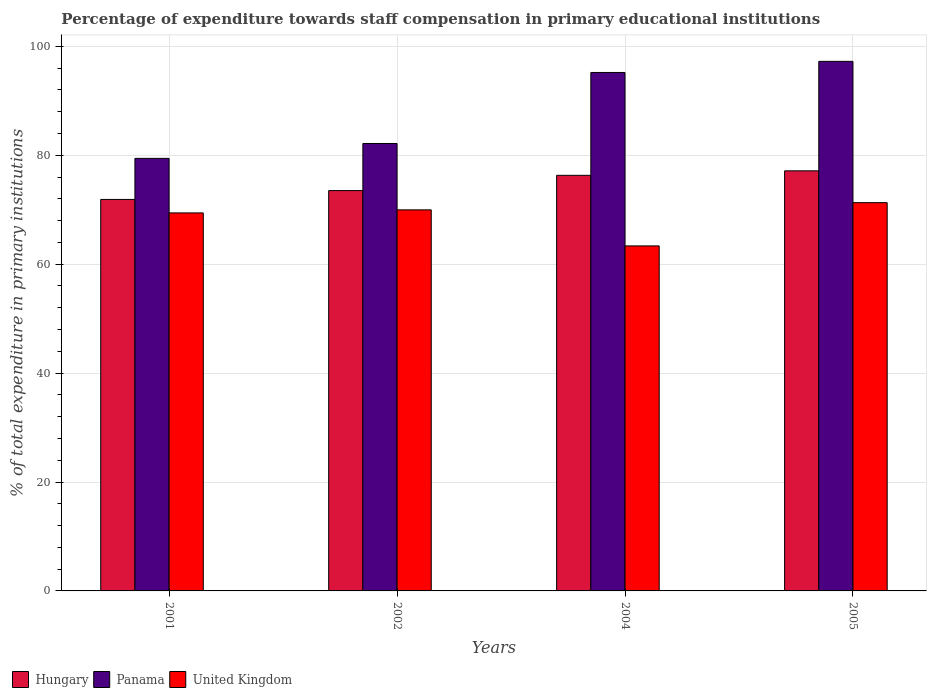How many different coloured bars are there?
Give a very brief answer. 3. Are the number of bars per tick equal to the number of legend labels?
Provide a short and direct response. Yes. What is the label of the 4th group of bars from the left?
Make the answer very short. 2005. What is the percentage of expenditure towards staff compensation in United Kingdom in 2004?
Your answer should be compact. 63.36. Across all years, what is the maximum percentage of expenditure towards staff compensation in Panama?
Keep it short and to the point. 97.25. Across all years, what is the minimum percentage of expenditure towards staff compensation in Hungary?
Provide a short and direct response. 71.89. What is the total percentage of expenditure towards staff compensation in Panama in the graph?
Your response must be concise. 354.05. What is the difference between the percentage of expenditure towards staff compensation in United Kingdom in 2004 and that in 2005?
Provide a short and direct response. -7.94. What is the difference between the percentage of expenditure towards staff compensation in Hungary in 2005 and the percentage of expenditure towards staff compensation in United Kingdom in 2002?
Give a very brief answer. 7.17. What is the average percentage of expenditure towards staff compensation in Panama per year?
Offer a terse response. 88.51. In the year 2002, what is the difference between the percentage of expenditure towards staff compensation in Hungary and percentage of expenditure towards staff compensation in United Kingdom?
Offer a terse response. 3.54. What is the ratio of the percentage of expenditure towards staff compensation in Hungary in 2002 to that in 2005?
Your answer should be very brief. 0.95. What is the difference between the highest and the second highest percentage of expenditure towards staff compensation in Hungary?
Give a very brief answer. 0.82. What is the difference between the highest and the lowest percentage of expenditure towards staff compensation in Panama?
Ensure brevity in your answer.  17.81. Is the sum of the percentage of expenditure towards staff compensation in Panama in 2002 and 2005 greater than the maximum percentage of expenditure towards staff compensation in United Kingdom across all years?
Keep it short and to the point. Yes. What does the 3rd bar from the left in 2002 represents?
Provide a short and direct response. United Kingdom. What does the 2nd bar from the right in 2004 represents?
Your response must be concise. Panama. Is it the case that in every year, the sum of the percentage of expenditure towards staff compensation in United Kingdom and percentage of expenditure towards staff compensation in Panama is greater than the percentage of expenditure towards staff compensation in Hungary?
Your response must be concise. Yes. How many bars are there?
Your response must be concise. 12. Are all the bars in the graph horizontal?
Offer a very short reply. No. How many years are there in the graph?
Ensure brevity in your answer.  4. Are the values on the major ticks of Y-axis written in scientific E-notation?
Offer a very short reply. No. Does the graph contain grids?
Offer a terse response. Yes. Where does the legend appear in the graph?
Keep it short and to the point. Bottom left. How are the legend labels stacked?
Provide a short and direct response. Horizontal. What is the title of the graph?
Your answer should be very brief. Percentage of expenditure towards staff compensation in primary educational institutions. Does "Sint Maarten (Dutch part)" appear as one of the legend labels in the graph?
Ensure brevity in your answer.  No. What is the label or title of the Y-axis?
Your response must be concise. % of total expenditure in primary institutions. What is the % of total expenditure in primary institutions of Hungary in 2001?
Your answer should be compact. 71.89. What is the % of total expenditure in primary institutions of Panama in 2001?
Provide a short and direct response. 79.43. What is the % of total expenditure in primary institutions of United Kingdom in 2001?
Offer a very short reply. 69.42. What is the % of total expenditure in primary institutions of Hungary in 2002?
Give a very brief answer. 73.52. What is the % of total expenditure in primary institutions of Panama in 2002?
Provide a succinct answer. 82.16. What is the % of total expenditure in primary institutions of United Kingdom in 2002?
Keep it short and to the point. 69.97. What is the % of total expenditure in primary institutions in Hungary in 2004?
Your answer should be very brief. 76.32. What is the % of total expenditure in primary institutions in Panama in 2004?
Keep it short and to the point. 95.21. What is the % of total expenditure in primary institutions in United Kingdom in 2004?
Keep it short and to the point. 63.36. What is the % of total expenditure in primary institutions of Hungary in 2005?
Provide a short and direct response. 77.14. What is the % of total expenditure in primary institutions in Panama in 2005?
Make the answer very short. 97.25. What is the % of total expenditure in primary institutions in United Kingdom in 2005?
Offer a very short reply. 71.3. Across all years, what is the maximum % of total expenditure in primary institutions in Hungary?
Ensure brevity in your answer.  77.14. Across all years, what is the maximum % of total expenditure in primary institutions of Panama?
Your answer should be compact. 97.25. Across all years, what is the maximum % of total expenditure in primary institutions in United Kingdom?
Give a very brief answer. 71.3. Across all years, what is the minimum % of total expenditure in primary institutions in Hungary?
Offer a very short reply. 71.89. Across all years, what is the minimum % of total expenditure in primary institutions in Panama?
Make the answer very short. 79.43. Across all years, what is the minimum % of total expenditure in primary institutions in United Kingdom?
Give a very brief answer. 63.36. What is the total % of total expenditure in primary institutions of Hungary in the graph?
Make the answer very short. 298.87. What is the total % of total expenditure in primary institutions of Panama in the graph?
Provide a short and direct response. 354.05. What is the total % of total expenditure in primary institutions of United Kingdom in the graph?
Your answer should be very brief. 274.05. What is the difference between the % of total expenditure in primary institutions in Hungary in 2001 and that in 2002?
Offer a very short reply. -1.62. What is the difference between the % of total expenditure in primary institutions in Panama in 2001 and that in 2002?
Provide a short and direct response. -2.73. What is the difference between the % of total expenditure in primary institutions in United Kingdom in 2001 and that in 2002?
Give a very brief answer. -0.56. What is the difference between the % of total expenditure in primary institutions of Hungary in 2001 and that in 2004?
Your answer should be very brief. -4.43. What is the difference between the % of total expenditure in primary institutions in Panama in 2001 and that in 2004?
Ensure brevity in your answer.  -15.78. What is the difference between the % of total expenditure in primary institutions of United Kingdom in 2001 and that in 2004?
Offer a terse response. 6.06. What is the difference between the % of total expenditure in primary institutions of Hungary in 2001 and that in 2005?
Provide a short and direct response. -5.25. What is the difference between the % of total expenditure in primary institutions in Panama in 2001 and that in 2005?
Your answer should be compact. -17.81. What is the difference between the % of total expenditure in primary institutions of United Kingdom in 2001 and that in 2005?
Keep it short and to the point. -1.88. What is the difference between the % of total expenditure in primary institutions of Hungary in 2002 and that in 2004?
Your answer should be compact. -2.8. What is the difference between the % of total expenditure in primary institutions of Panama in 2002 and that in 2004?
Ensure brevity in your answer.  -13.04. What is the difference between the % of total expenditure in primary institutions in United Kingdom in 2002 and that in 2004?
Make the answer very short. 6.62. What is the difference between the % of total expenditure in primary institutions of Hungary in 2002 and that in 2005?
Ensure brevity in your answer.  -3.63. What is the difference between the % of total expenditure in primary institutions in Panama in 2002 and that in 2005?
Your answer should be very brief. -15.08. What is the difference between the % of total expenditure in primary institutions in United Kingdom in 2002 and that in 2005?
Provide a succinct answer. -1.32. What is the difference between the % of total expenditure in primary institutions in Hungary in 2004 and that in 2005?
Make the answer very short. -0.82. What is the difference between the % of total expenditure in primary institutions in Panama in 2004 and that in 2005?
Offer a very short reply. -2.04. What is the difference between the % of total expenditure in primary institutions of United Kingdom in 2004 and that in 2005?
Ensure brevity in your answer.  -7.94. What is the difference between the % of total expenditure in primary institutions of Hungary in 2001 and the % of total expenditure in primary institutions of Panama in 2002?
Your response must be concise. -10.27. What is the difference between the % of total expenditure in primary institutions of Hungary in 2001 and the % of total expenditure in primary institutions of United Kingdom in 2002?
Keep it short and to the point. 1.92. What is the difference between the % of total expenditure in primary institutions of Panama in 2001 and the % of total expenditure in primary institutions of United Kingdom in 2002?
Provide a succinct answer. 9.46. What is the difference between the % of total expenditure in primary institutions of Hungary in 2001 and the % of total expenditure in primary institutions of Panama in 2004?
Offer a terse response. -23.32. What is the difference between the % of total expenditure in primary institutions of Hungary in 2001 and the % of total expenditure in primary institutions of United Kingdom in 2004?
Offer a very short reply. 8.54. What is the difference between the % of total expenditure in primary institutions of Panama in 2001 and the % of total expenditure in primary institutions of United Kingdom in 2004?
Offer a terse response. 16.08. What is the difference between the % of total expenditure in primary institutions of Hungary in 2001 and the % of total expenditure in primary institutions of Panama in 2005?
Offer a very short reply. -25.36. What is the difference between the % of total expenditure in primary institutions of Hungary in 2001 and the % of total expenditure in primary institutions of United Kingdom in 2005?
Ensure brevity in your answer.  0.59. What is the difference between the % of total expenditure in primary institutions in Panama in 2001 and the % of total expenditure in primary institutions in United Kingdom in 2005?
Your answer should be very brief. 8.13. What is the difference between the % of total expenditure in primary institutions in Hungary in 2002 and the % of total expenditure in primary institutions in Panama in 2004?
Provide a short and direct response. -21.69. What is the difference between the % of total expenditure in primary institutions in Hungary in 2002 and the % of total expenditure in primary institutions in United Kingdom in 2004?
Your response must be concise. 10.16. What is the difference between the % of total expenditure in primary institutions in Panama in 2002 and the % of total expenditure in primary institutions in United Kingdom in 2004?
Your answer should be compact. 18.81. What is the difference between the % of total expenditure in primary institutions of Hungary in 2002 and the % of total expenditure in primary institutions of Panama in 2005?
Ensure brevity in your answer.  -23.73. What is the difference between the % of total expenditure in primary institutions of Hungary in 2002 and the % of total expenditure in primary institutions of United Kingdom in 2005?
Give a very brief answer. 2.22. What is the difference between the % of total expenditure in primary institutions in Panama in 2002 and the % of total expenditure in primary institutions in United Kingdom in 2005?
Provide a short and direct response. 10.86. What is the difference between the % of total expenditure in primary institutions of Hungary in 2004 and the % of total expenditure in primary institutions of Panama in 2005?
Your answer should be compact. -20.93. What is the difference between the % of total expenditure in primary institutions in Hungary in 2004 and the % of total expenditure in primary institutions in United Kingdom in 2005?
Provide a short and direct response. 5.02. What is the difference between the % of total expenditure in primary institutions of Panama in 2004 and the % of total expenditure in primary institutions of United Kingdom in 2005?
Make the answer very short. 23.91. What is the average % of total expenditure in primary institutions of Hungary per year?
Offer a very short reply. 74.72. What is the average % of total expenditure in primary institutions of Panama per year?
Offer a very short reply. 88.51. What is the average % of total expenditure in primary institutions in United Kingdom per year?
Keep it short and to the point. 68.51. In the year 2001, what is the difference between the % of total expenditure in primary institutions of Hungary and % of total expenditure in primary institutions of Panama?
Offer a terse response. -7.54. In the year 2001, what is the difference between the % of total expenditure in primary institutions of Hungary and % of total expenditure in primary institutions of United Kingdom?
Your answer should be compact. 2.47. In the year 2001, what is the difference between the % of total expenditure in primary institutions in Panama and % of total expenditure in primary institutions in United Kingdom?
Make the answer very short. 10.02. In the year 2002, what is the difference between the % of total expenditure in primary institutions in Hungary and % of total expenditure in primary institutions in Panama?
Give a very brief answer. -8.65. In the year 2002, what is the difference between the % of total expenditure in primary institutions in Hungary and % of total expenditure in primary institutions in United Kingdom?
Give a very brief answer. 3.54. In the year 2002, what is the difference between the % of total expenditure in primary institutions in Panama and % of total expenditure in primary institutions in United Kingdom?
Ensure brevity in your answer.  12.19. In the year 2004, what is the difference between the % of total expenditure in primary institutions in Hungary and % of total expenditure in primary institutions in Panama?
Provide a succinct answer. -18.89. In the year 2004, what is the difference between the % of total expenditure in primary institutions in Hungary and % of total expenditure in primary institutions in United Kingdom?
Give a very brief answer. 12.96. In the year 2004, what is the difference between the % of total expenditure in primary institutions of Panama and % of total expenditure in primary institutions of United Kingdom?
Make the answer very short. 31.85. In the year 2005, what is the difference between the % of total expenditure in primary institutions in Hungary and % of total expenditure in primary institutions in Panama?
Give a very brief answer. -20.11. In the year 2005, what is the difference between the % of total expenditure in primary institutions of Hungary and % of total expenditure in primary institutions of United Kingdom?
Offer a terse response. 5.84. In the year 2005, what is the difference between the % of total expenditure in primary institutions of Panama and % of total expenditure in primary institutions of United Kingdom?
Your answer should be compact. 25.95. What is the ratio of the % of total expenditure in primary institutions in Hungary in 2001 to that in 2002?
Keep it short and to the point. 0.98. What is the ratio of the % of total expenditure in primary institutions of Panama in 2001 to that in 2002?
Ensure brevity in your answer.  0.97. What is the ratio of the % of total expenditure in primary institutions of United Kingdom in 2001 to that in 2002?
Give a very brief answer. 0.99. What is the ratio of the % of total expenditure in primary institutions of Hungary in 2001 to that in 2004?
Offer a very short reply. 0.94. What is the ratio of the % of total expenditure in primary institutions in Panama in 2001 to that in 2004?
Your answer should be very brief. 0.83. What is the ratio of the % of total expenditure in primary institutions of United Kingdom in 2001 to that in 2004?
Your answer should be very brief. 1.1. What is the ratio of the % of total expenditure in primary institutions in Hungary in 2001 to that in 2005?
Make the answer very short. 0.93. What is the ratio of the % of total expenditure in primary institutions in Panama in 2001 to that in 2005?
Your response must be concise. 0.82. What is the ratio of the % of total expenditure in primary institutions in United Kingdom in 2001 to that in 2005?
Your response must be concise. 0.97. What is the ratio of the % of total expenditure in primary institutions in Hungary in 2002 to that in 2004?
Offer a terse response. 0.96. What is the ratio of the % of total expenditure in primary institutions of Panama in 2002 to that in 2004?
Your answer should be very brief. 0.86. What is the ratio of the % of total expenditure in primary institutions in United Kingdom in 2002 to that in 2004?
Ensure brevity in your answer.  1.1. What is the ratio of the % of total expenditure in primary institutions of Hungary in 2002 to that in 2005?
Your answer should be very brief. 0.95. What is the ratio of the % of total expenditure in primary institutions of Panama in 2002 to that in 2005?
Give a very brief answer. 0.84. What is the ratio of the % of total expenditure in primary institutions of United Kingdom in 2002 to that in 2005?
Keep it short and to the point. 0.98. What is the ratio of the % of total expenditure in primary institutions in Hungary in 2004 to that in 2005?
Provide a succinct answer. 0.99. What is the ratio of the % of total expenditure in primary institutions in United Kingdom in 2004 to that in 2005?
Ensure brevity in your answer.  0.89. What is the difference between the highest and the second highest % of total expenditure in primary institutions in Hungary?
Make the answer very short. 0.82. What is the difference between the highest and the second highest % of total expenditure in primary institutions in Panama?
Keep it short and to the point. 2.04. What is the difference between the highest and the second highest % of total expenditure in primary institutions in United Kingdom?
Offer a very short reply. 1.32. What is the difference between the highest and the lowest % of total expenditure in primary institutions in Hungary?
Your answer should be compact. 5.25. What is the difference between the highest and the lowest % of total expenditure in primary institutions of Panama?
Your answer should be very brief. 17.81. What is the difference between the highest and the lowest % of total expenditure in primary institutions of United Kingdom?
Your answer should be very brief. 7.94. 